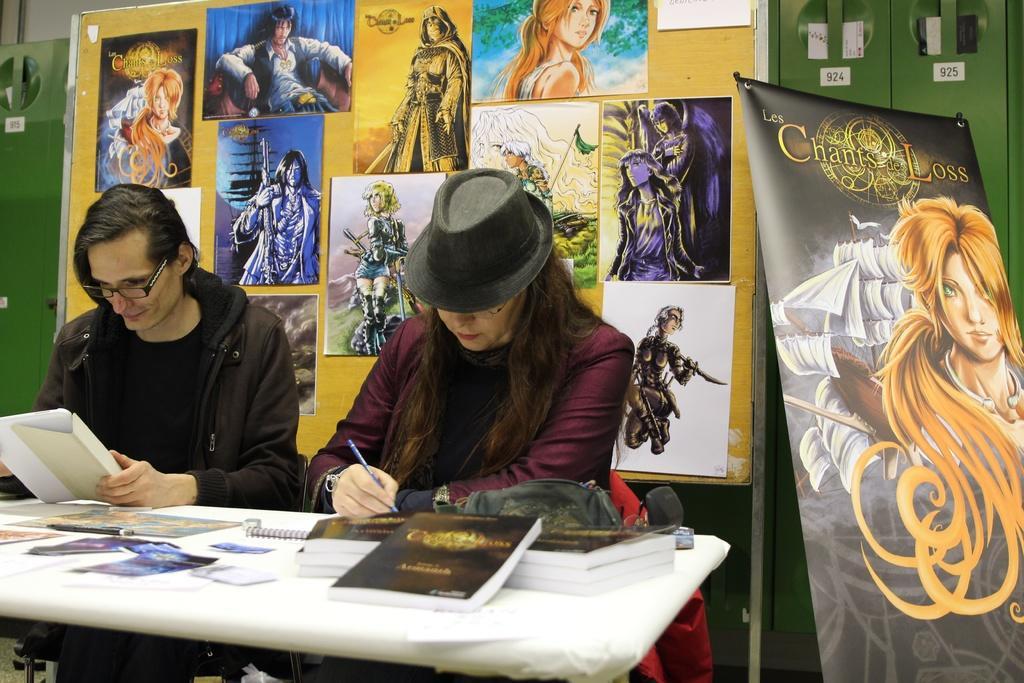In one or two sentences, can you explain what this image depicts? In this image I can see two people with different color dresses and one person with the hat. These people are holding a pen and the papers. In-front of these people I can see the books, papers and posters. In the background I can see the posts to the board and the banner. I can see the green color lockers and the wall. 